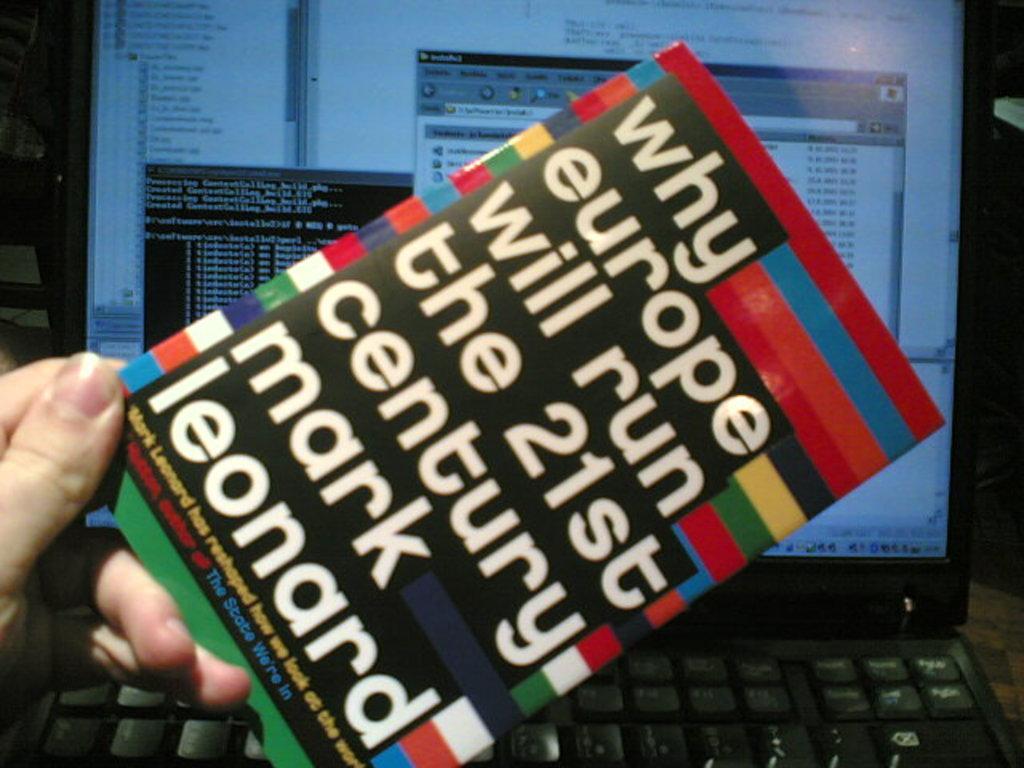What century is mentioned?
Keep it short and to the point. 21st. What country is mentioned in the title of the book?
Make the answer very short. Europe. 